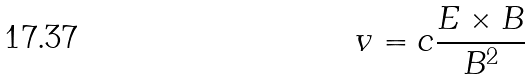Convert formula to latex. <formula><loc_0><loc_0><loc_500><loc_500>v = c { \frac { E \times B } { B ^ { 2 } } }</formula> 